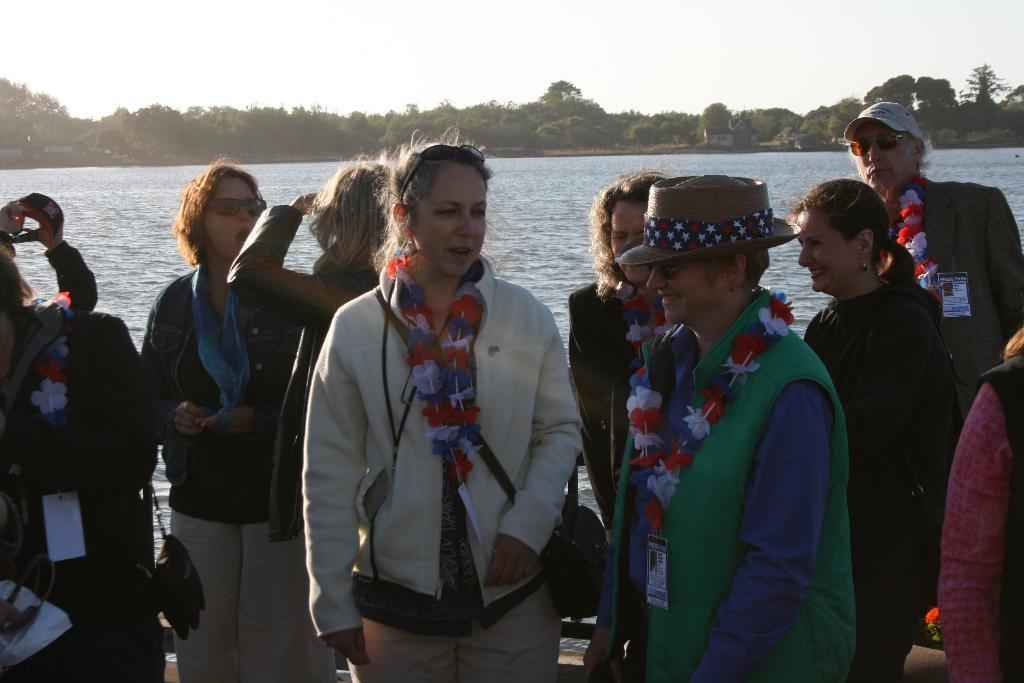What is the main subject in the foreground of the picture? There is a group of people in the foreground of the picture. What can be seen in the center of the picture? There is a water body in the center of the picture. What type of vegetation is present in the picture? There are trees in the picture. What is visible at the top of the picture? The sky is visible at the top of the picture. Can you tell me how many matches are being used by the group of people in the picture? There is no mention of matches or any similar objects in the image, so it is not possible to determine if any matches are being used. What scene is depicted in the background of the picture? The provided facts do not mention any specific scene or background, so it cannot be determined from the information given. 